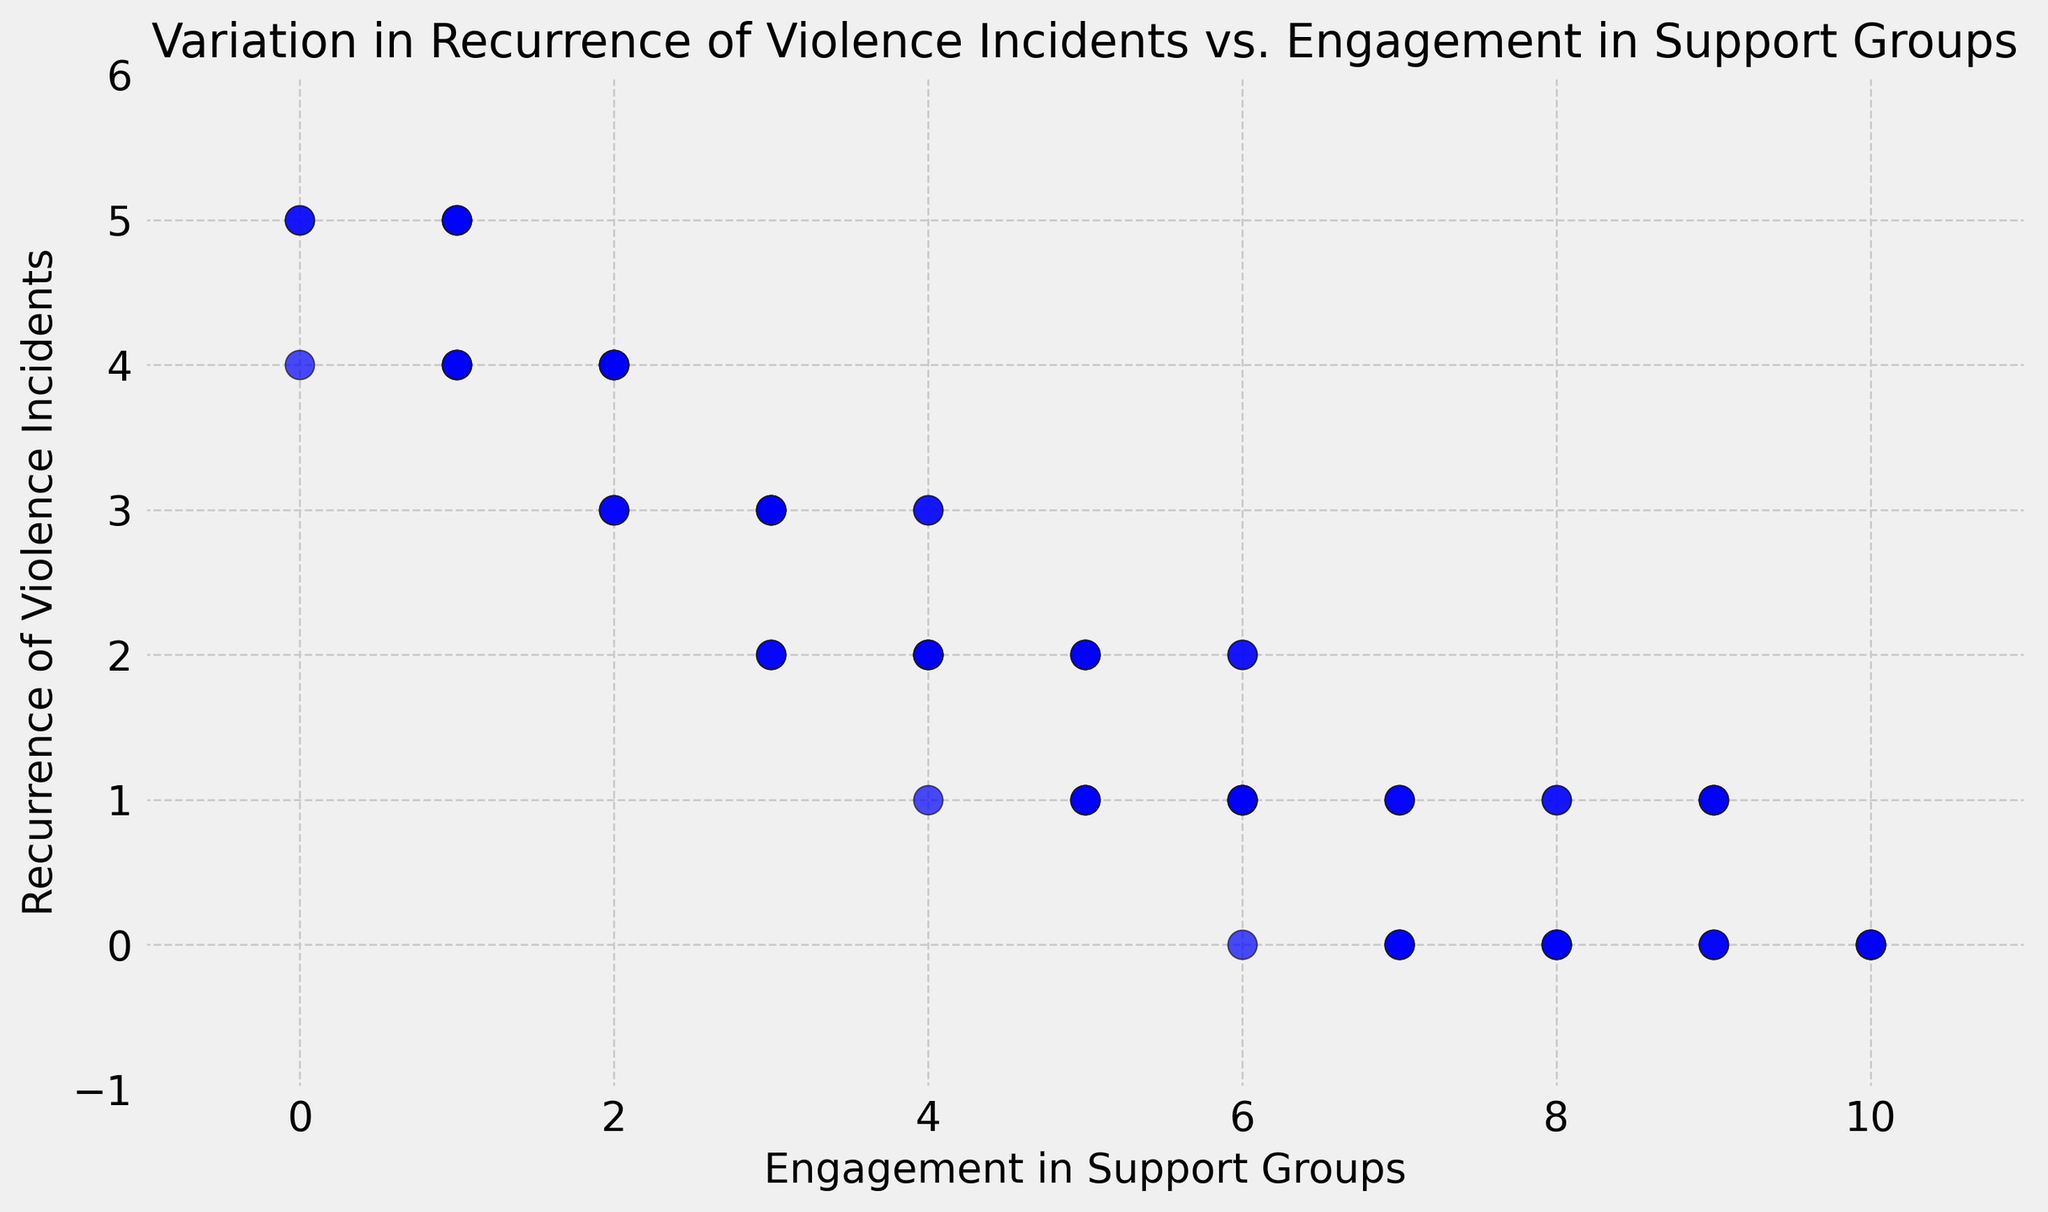How does the recurrence of violence incidents change as engagement in support groups increases? As engagement in support groups increases (moving along the x-axis), the recurrence of violence incidents generally decreases (moving down the y-axis). This can be observed from the negative trend in the scatter plot.
Answer: It decreases Which levels of engagement (specific values) have the lowest recurrence of violence incidents? Observing the scatter plot, the lowest recurrence (0 incidents) occurs at engagement levels of 8, 9, and 10 in support groups.
Answer: 8, 9, 10 What is the average number of recurrence incidents for an engagement level of 5? Referring to the plot, the points for engagement level 5 are (5,2), (5,2), (5,1), (5,1), and (5,1). Calculating the average: (2+2+1+1+1)/5 = 7/5 = 1.4.
Answer: 1.4 Which engagement level shows the highest recurrence of violence incidents and what is the value? The scatter plot shows the highest recurrence of 5 incidents occurs at engagement levels 0 and 1.
Answer: 0 and 1, 5 incidents Is there any engagement level where the recurrence of violence incidents is consistent (the same value for all instances)? Observing engagement levels in the scatter plot, engagement levels like 7 and 10 consistently show 0 incidents, and level 9 predominantly shows 1 incident.
Answer: 7, 10 How does the recurrence of violence incidents for an engagement level of 3 compare to that of level 6? For engagement level 3, the frequent values are 3 and 2. For level 6, the frequent values are 2, 1, and 0. Engagement level 3 shows higher values compared to level 6.
Answer: Level 3 is higher than level 6 What is the range of the recurrence of violence incidents for an engagement level of 4? Referring to the scatter plot, the recurrence incidents at engagement level 4 vary between 1 to 3. The range is calculated as 3 - 1 = 2.
Answer: 2 Which engagement in support groups level has the most varied recurrence of violence incidents? Noting the spread of points, engagement levels like 1 and 4 show a wider range (5 and 1-3 respectively). Level 1 shows the greatest variation from 4 to 5.
Answer: 1 